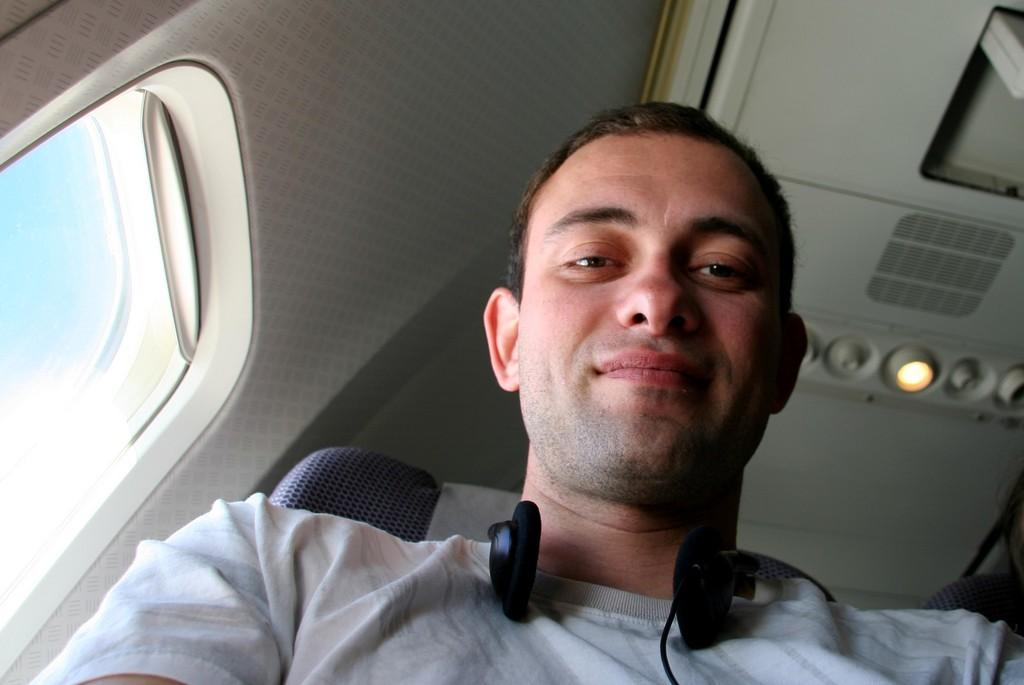What is the main subject of the image? The main subject of the image is a man. What is the man wearing in the image? The man is wearing headphones in the image. What is the man's facial expression in the image? The man is smiling in the image. What architectural feature can be seen in the image? There is a window in the image. Is there a hat visible on the man in the image? No, there is no hat visible on the man in the image. Is there a party happening in the image? There is no indication of a party in the image, as it only shows a man wearing headphones and smiling. 